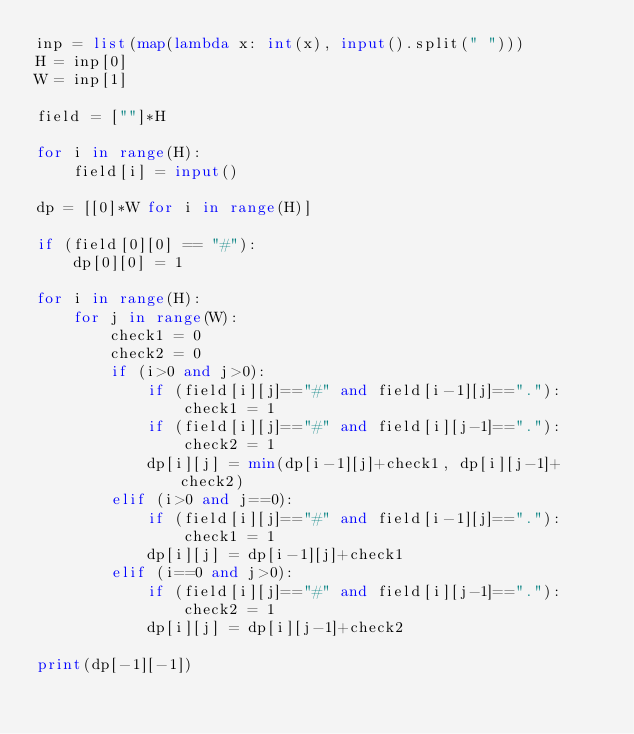Convert code to text. <code><loc_0><loc_0><loc_500><loc_500><_Python_>inp = list(map(lambda x: int(x), input().split(" ")))
H = inp[0]
W = inp[1]

field = [""]*H

for i in range(H):
    field[i] = input()

dp = [[0]*W for i in range(H)]

if (field[0][0] == "#"):
    dp[0][0] = 1

for i in range(H):
    for j in range(W):
        check1 = 0
        check2 = 0
        if (i>0 and j>0):
            if (field[i][j]=="#" and field[i-1][j]=="."):
                check1 = 1
            if (field[i][j]=="#" and field[i][j-1]=="."):
                check2 = 1
            dp[i][j] = min(dp[i-1][j]+check1, dp[i][j-1]+check2)
        elif (i>0 and j==0):
            if (field[i][j]=="#" and field[i-1][j]=="."):
                check1 = 1
            dp[i][j] = dp[i-1][j]+check1
        elif (i==0 and j>0):
            if (field[i][j]=="#" and field[i][j-1]=="."):
                check2 = 1
            dp[i][j] = dp[i][j-1]+check2

print(dp[-1][-1])</code> 